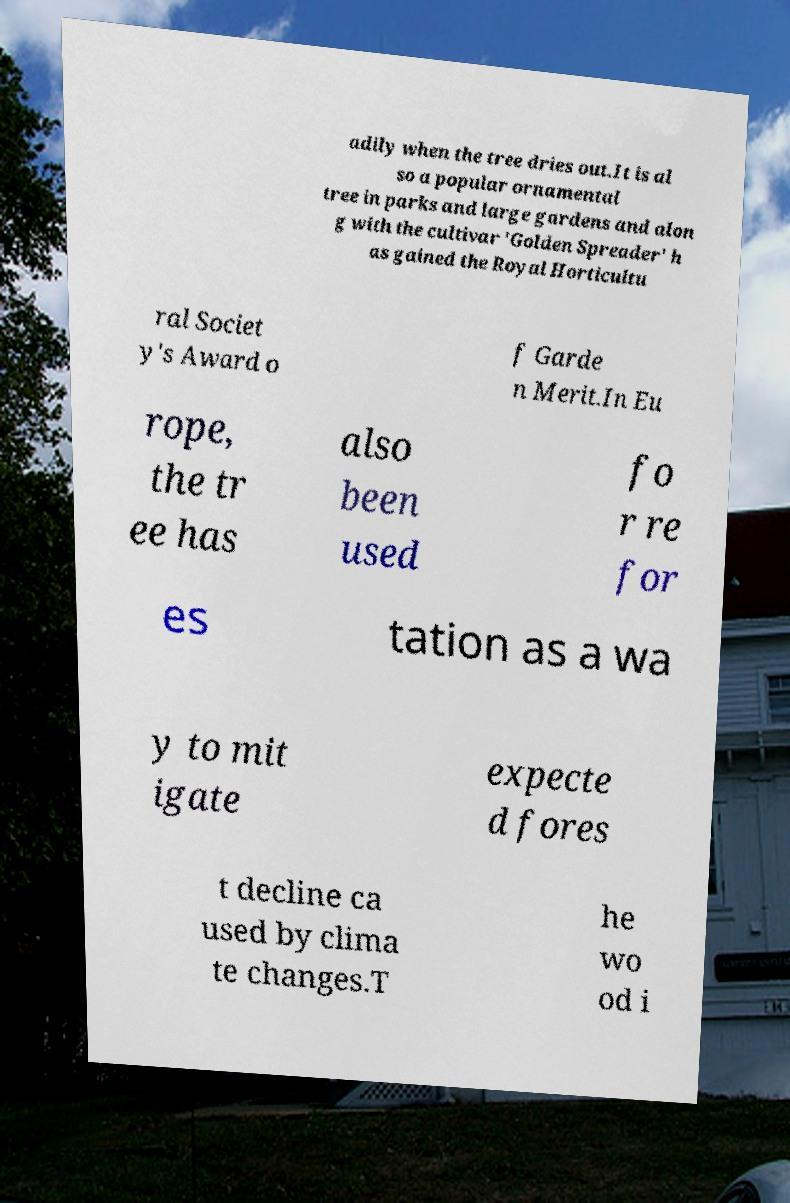Please identify and transcribe the text found in this image. adily when the tree dries out.It is al so a popular ornamental tree in parks and large gardens and alon g with the cultivar 'Golden Spreader' h as gained the Royal Horticultu ral Societ y's Award o f Garde n Merit.In Eu rope, the tr ee has also been used fo r re for es tation as a wa y to mit igate expecte d fores t decline ca used by clima te changes.T he wo od i 